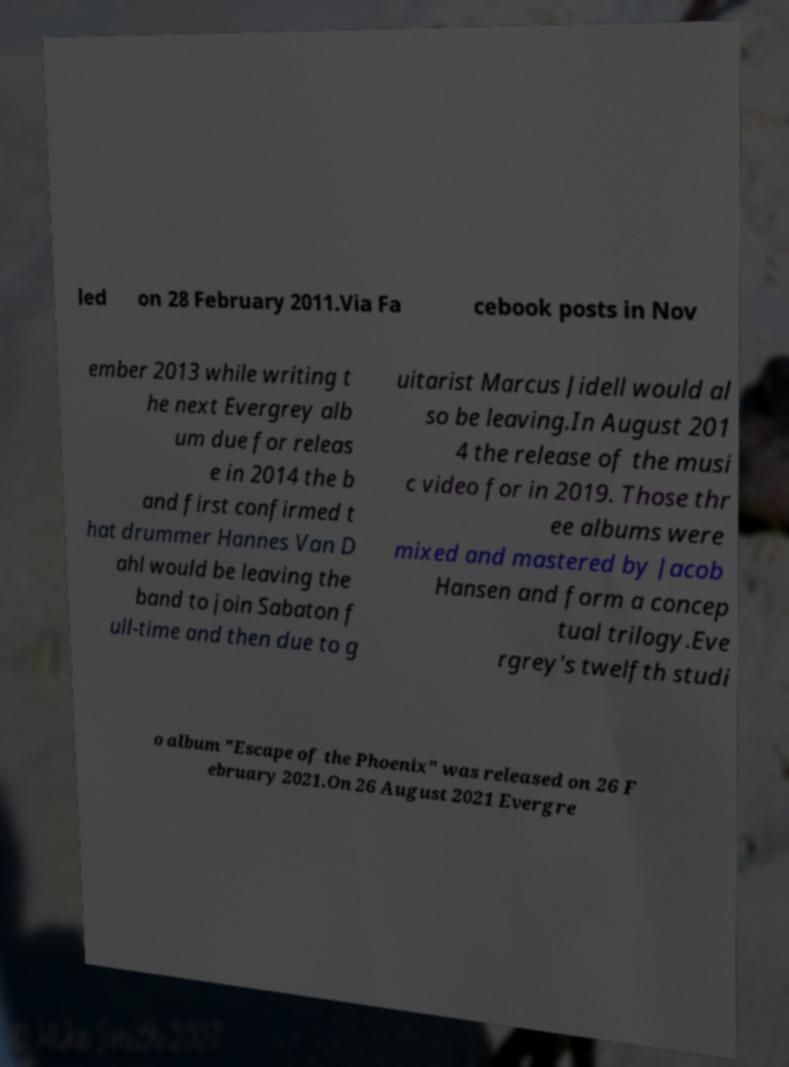Please identify and transcribe the text found in this image. led on 28 February 2011.Via Fa cebook posts in Nov ember 2013 while writing t he next Evergrey alb um due for releas e in 2014 the b and first confirmed t hat drummer Hannes Van D ahl would be leaving the band to join Sabaton f ull-time and then due to g uitarist Marcus Jidell would al so be leaving.In August 201 4 the release of the musi c video for in 2019. Those thr ee albums were mixed and mastered by Jacob Hansen and form a concep tual trilogy.Eve rgrey's twelfth studi o album "Escape of the Phoenix" was released on 26 F ebruary 2021.On 26 August 2021 Evergre 